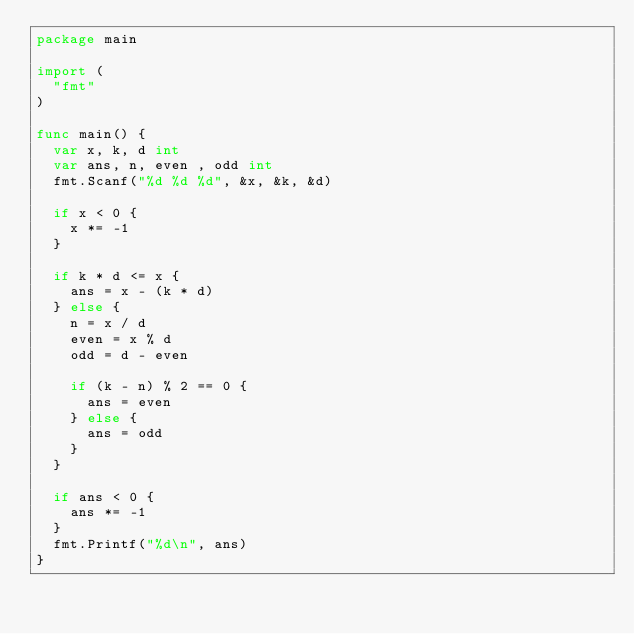<code> <loc_0><loc_0><loc_500><loc_500><_Go_>package main

import (
  "fmt"
)

func main() {
  var x, k, d int
  var ans, n, even , odd int
  fmt.Scanf("%d %d %d", &x, &k, &d)

  if x < 0 {
    x *= -1
  }
  
  if k * d <= x {
    ans = x - (k * d)
  } else {
    n = x / d
    even = x % d
    odd = d - even
    
    if (k - n) % 2 == 0 {
      ans = even
    } else {
      ans = odd
    }
  }
  
  if ans < 0 {
    ans *= -1
  }
  fmt.Printf("%d\n", ans)
}</code> 